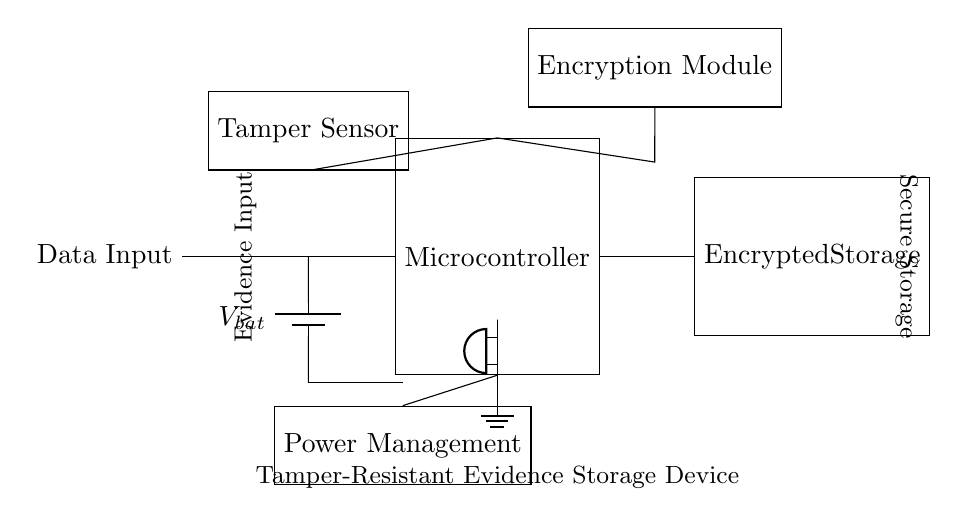What is the main component of the circuit? The main component is the microcontroller, which is represented as a rectangle labeled "Microcontroller" at the center of the circuit.
Answer: Microcontroller What is the purpose of the encryption module? The encryption module is used to securely encrypt data that is being stored, ensuring that the information is protected from unauthorized access. It is connected to the microcontroller above it in the circuit.
Answer: Secure storage How many main modules are connected to the microcontroller? The microcontroller has connections to three main modules: the encryption module, tamper sensor, and encrypted storage, as indicated by the lines connecting these components to it.
Answer: Three What is the role of the tamper sensor? The tamper sensor detects any unauthorized access or tampering with the device, alerting the microcontroller to respond appropriately, which is crucial for maintaining the integrity of the stored evidence.
Answer: Tamper detection What power source is used in this circuit? The power source for the circuit is a battery, labeled as "Vbat", which is located at the left side of the diagram and supplies power to the microcontroller and other components.
Answer: Battery What type of output does the circuit use for alarm signaling? The circuit utilizes a buzzer connected to the microcontroller for alarm output, indicating a tampering event when triggered. The buzzer is positioned below the microcontroller in the circuit diagram.
Answer: Buzzer What safety feature is indicated in the circuit design? The safety feature is the tamper detection sensor, which plays a crucial role in enhancing the security of the evidence storage by monitoring for unauthorized access and tampering attempts.
Answer: Tamper sensor 